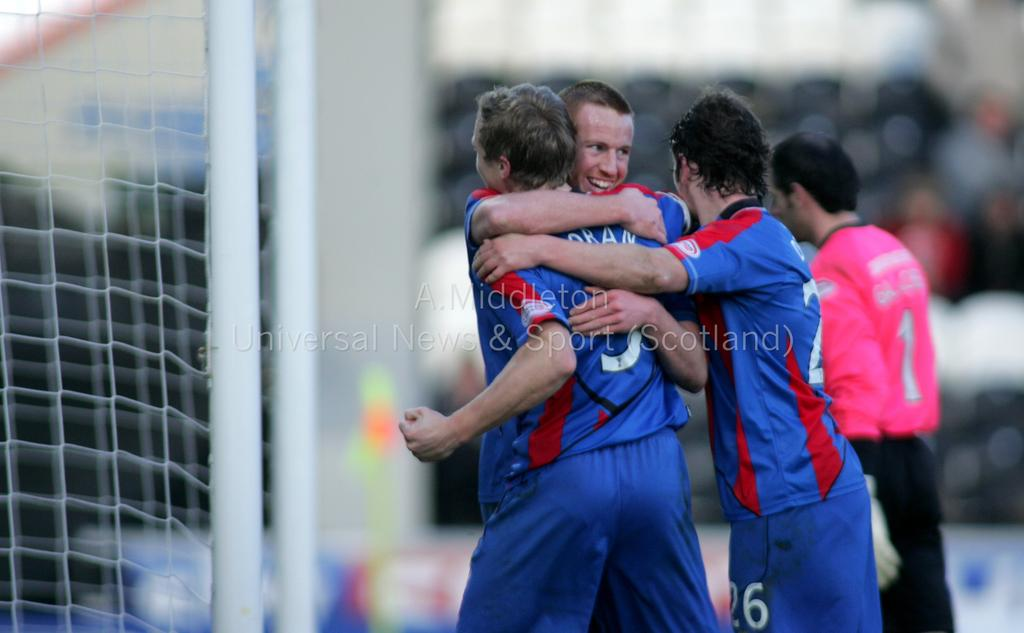<image>
Write a terse but informative summary of the picture. Players in blue uniforms celebrate on the field in a photo with A. Middleton watermark on it. 